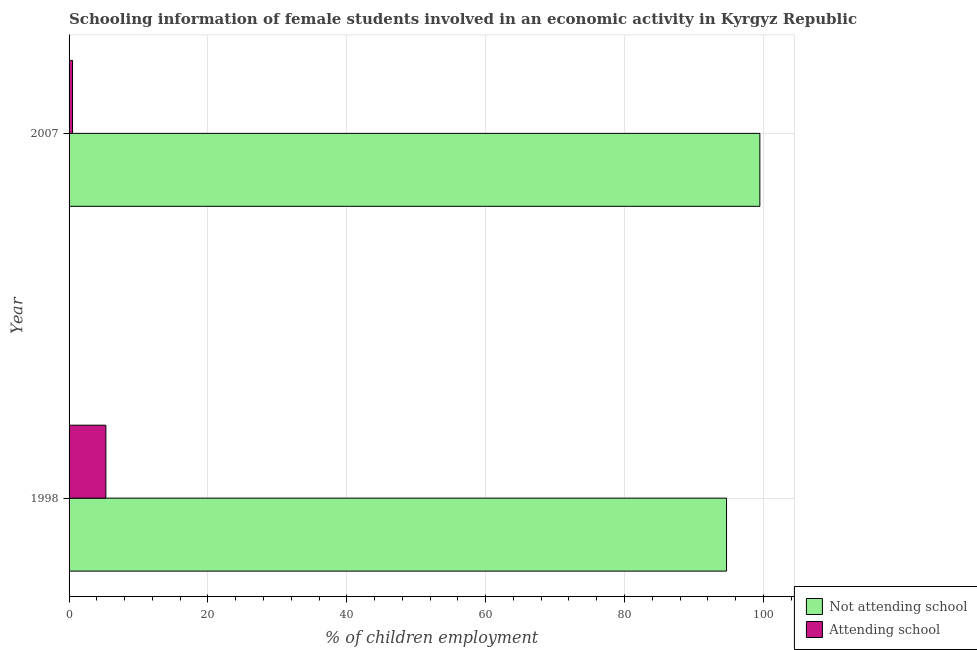Are the number of bars per tick equal to the number of legend labels?
Provide a short and direct response. Yes. How many bars are there on the 2nd tick from the top?
Ensure brevity in your answer.  2. How many bars are there on the 1st tick from the bottom?
Your answer should be very brief. 2. In how many cases, is the number of bars for a given year not equal to the number of legend labels?
Give a very brief answer. 0. What is the percentage of employed females who are attending school in 1998?
Give a very brief answer. 5.3. Across all years, what is the maximum percentage of employed females who are not attending school?
Your answer should be compact. 99.5. Across all years, what is the minimum percentage of employed females who are not attending school?
Give a very brief answer. 94.7. In which year was the percentage of employed females who are not attending school maximum?
Ensure brevity in your answer.  2007. What is the total percentage of employed females who are not attending school in the graph?
Offer a terse response. 194.2. What is the difference between the percentage of employed females who are not attending school in 1998 and that in 2007?
Keep it short and to the point. -4.8. What is the difference between the percentage of employed females who are attending school in 1998 and the percentage of employed females who are not attending school in 2007?
Your answer should be compact. -94.2. In the year 1998, what is the difference between the percentage of employed females who are not attending school and percentage of employed females who are attending school?
Your answer should be compact. 89.4. What is the ratio of the percentage of employed females who are attending school in 1998 to that in 2007?
Keep it short and to the point. 10.6. Is the percentage of employed females who are attending school in 1998 less than that in 2007?
Offer a very short reply. No. In how many years, is the percentage of employed females who are attending school greater than the average percentage of employed females who are attending school taken over all years?
Make the answer very short. 1. What does the 1st bar from the top in 2007 represents?
Your answer should be very brief. Attending school. What does the 2nd bar from the bottom in 1998 represents?
Your answer should be very brief. Attending school. How many bars are there?
Ensure brevity in your answer.  4. What is the difference between two consecutive major ticks on the X-axis?
Your answer should be compact. 20. Are the values on the major ticks of X-axis written in scientific E-notation?
Your answer should be compact. No. Does the graph contain grids?
Keep it short and to the point. Yes. How many legend labels are there?
Your answer should be compact. 2. What is the title of the graph?
Your answer should be very brief. Schooling information of female students involved in an economic activity in Kyrgyz Republic. Does "Mineral" appear as one of the legend labels in the graph?
Offer a very short reply. No. What is the label or title of the X-axis?
Your response must be concise. % of children employment. What is the label or title of the Y-axis?
Ensure brevity in your answer.  Year. What is the % of children employment of Not attending school in 1998?
Offer a very short reply. 94.7. What is the % of children employment in Not attending school in 2007?
Keep it short and to the point. 99.5. What is the % of children employment in Attending school in 2007?
Your answer should be compact. 0.5. Across all years, what is the maximum % of children employment in Not attending school?
Offer a terse response. 99.5. Across all years, what is the maximum % of children employment in Attending school?
Your answer should be compact. 5.3. Across all years, what is the minimum % of children employment in Not attending school?
Your response must be concise. 94.7. Across all years, what is the minimum % of children employment of Attending school?
Make the answer very short. 0.5. What is the total % of children employment in Not attending school in the graph?
Provide a succinct answer. 194.2. What is the difference between the % of children employment in Not attending school in 1998 and that in 2007?
Ensure brevity in your answer.  -4.8. What is the difference between the % of children employment of Not attending school in 1998 and the % of children employment of Attending school in 2007?
Provide a short and direct response. 94.2. What is the average % of children employment in Not attending school per year?
Keep it short and to the point. 97.1. What is the average % of children employment of Attending school per year?
Your answer should be compact. 2.9. In the year 1998, what is the difference between the % of children employment in Not attending school and % of children employment in Attending school?
Provide a short and direct response. 89.4. In the year 2007, what is the difference between the % of children employment in Not attending school and % of children employment in Attending school?
Give a very brief answer. 99. What is the ratio of the % of children employment of Not attending school in 1998 to that in 2007?
Make the answer very short. 0.95. What is the difference between the highest and the second highest % of children employment in Attending school?
Your answer should be very brief. 4.8. 